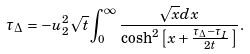<formula> <loc_0><loc_0><loc_500><loc_500>\tau _ { \Delta } = - u _ { 2 } ^ { 2 } \sqrt { t } \int _ { 0 } ^ { \infty } \frac { \sqrt { x } d x } { \cosh ^ { 2 } { \left [ x + \frac { \tau _ { \Delta } - \tau _ { I } } { 2 t } \, \right ] } } \, .</formula> 